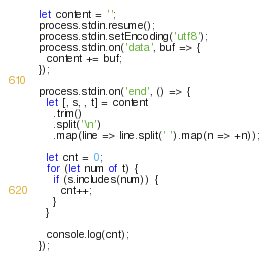<code> <loc_0><loc_0><loc_500><loc_500><_JavaScript_>let content = '';
process.stdin.resume();
process.stdin.setEncoding('utf8');
process.stdin.on('data', buf => {
  content += buf;
});

process.stdin.on('end', () => {
  let [, s, , t] = content
    .trim()
    .split('\n')
    .map(line => line.split(' ').map(n => +n));

  let cnt = 0;
  for (let num of t) {
    if (s.includes(num)) {
      cnt++;
    }
  }

  console.log(cnt);
});

</code> 